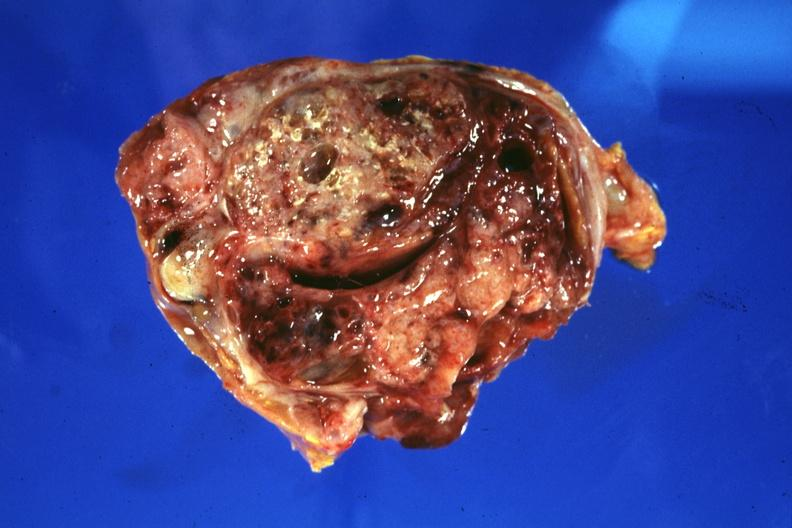s sacrococcygeal teratoma present?
Answer the question using a single word or phrase. Yes 